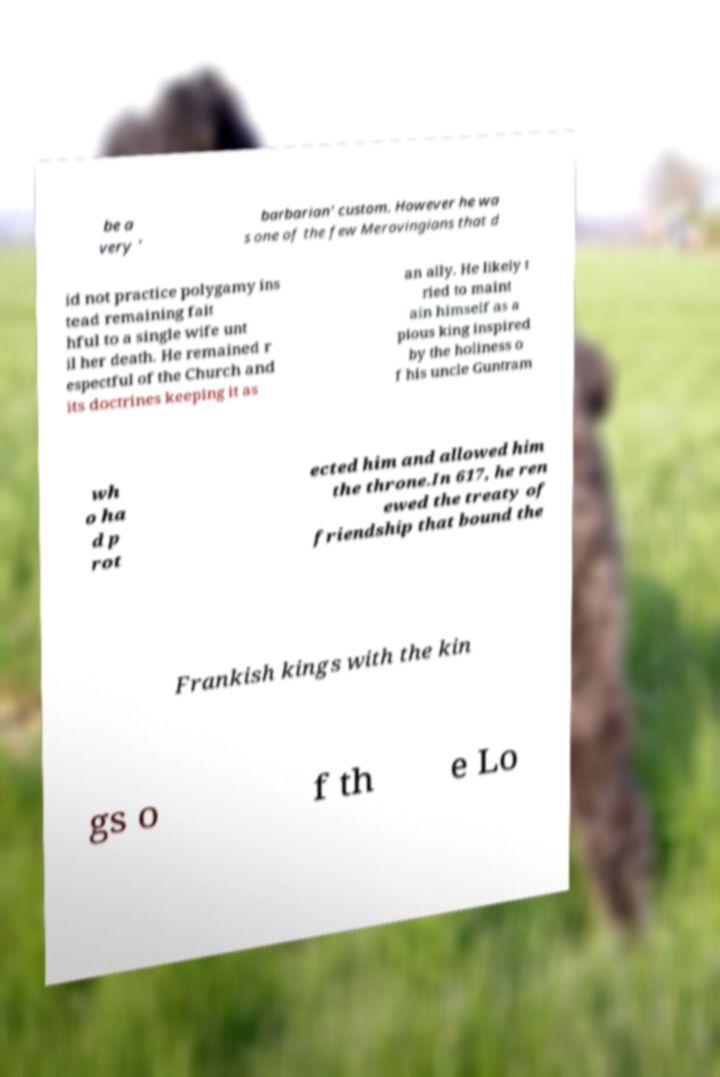Could you extract and type out the text from this image? be a very ' barbarian' custom. However he wa s one of the few Merovingians that d id not practice polygamy ins tead remaining fait hful to a single wife unt il her death. He remained r espectful of the Church and its doctrines keeping it as an ally. He likely t ried to maint ain himself as a pious king inspired by the holiness o f his uncle Guntram wh o ha d p rot ected him and allowed him the throne.In 617, he ren ewed the treaty of friendship that bound the Frankish kings with the kin gs o f th e Lo 